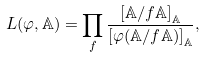Convert formula to latex. <formula><loc_0><loc_0><loc_500><loc_500>L ( \varphi , \mathbb { A } ) = \prod _ { f } \frac { \left [ \mathbb { A } / f \mathbb { A } \right ] _ { \mathbb { A } } } { \left [ \varphi ( \mathbb { A } / f \mathbb { A } ) \right ] _ { \mathbb { A } } } ,</formula> 